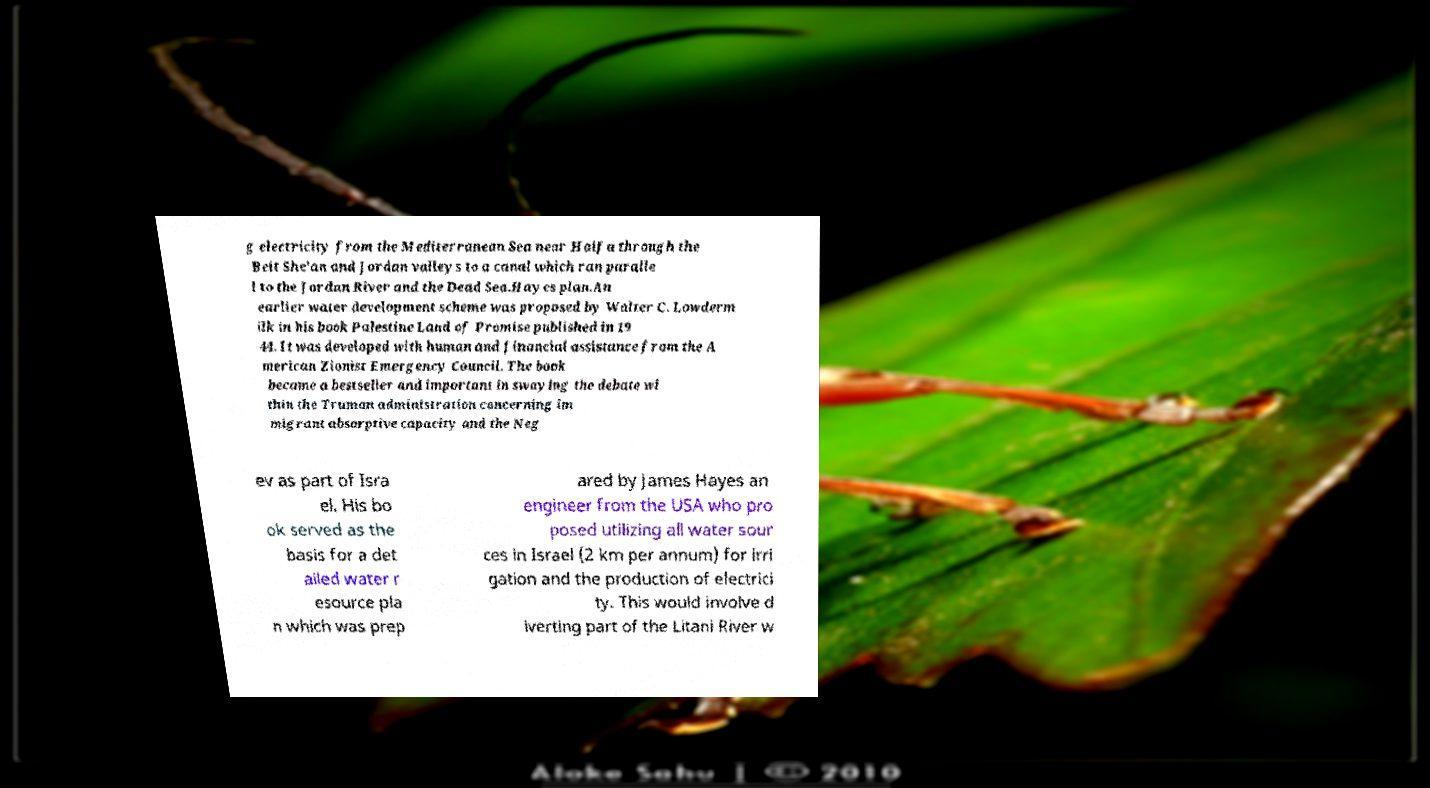Please identify and transcribe the text found in this image. g electricity from the Mediterranean Sea near Haifa through the Beit She'an and Jordan valleys to a canal which ran paralle l to the Jordan River and the Dead Sea.Hayes plan.An earlier water development scheme was proposed by Walter C. Lowderm ilk in his book Palestine Land of Promise published in 19 44. It was developed with human and financial assistance from the A merican Zionist Emergency Council. The book became a bestseller and important in swaying the debate wi thin the Truman administration concerning im migrant absorptive capacity and the Neg ev as part of Isra el. His bo ok served as the basis for a det ailed water r esource pla n which was prep ared by James Hayes an engineer from the USA who pro posed utilizing all water sour ces in Israel (2 km per annum) for irri gation and the production of electrici ty. This would involve d iverting part of the Litani River w 